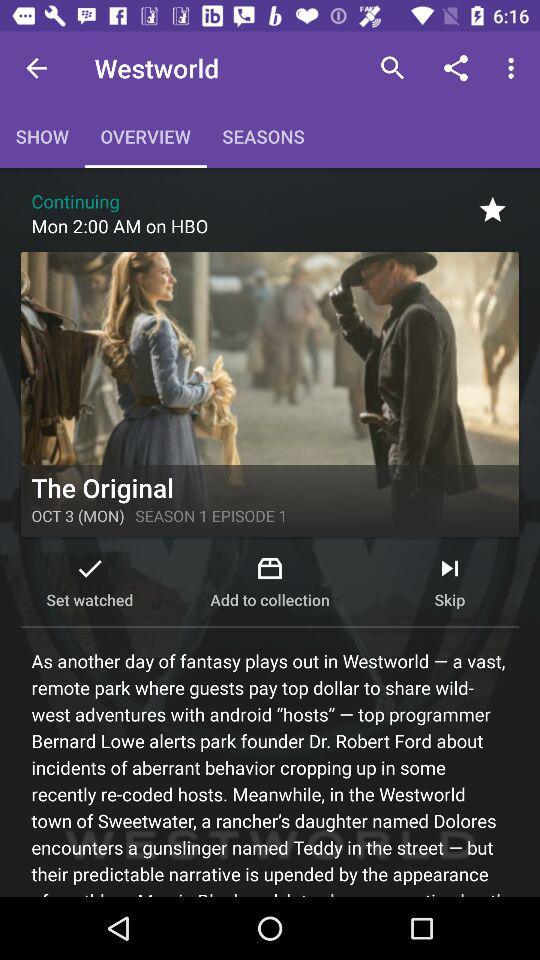What is the season of the drama? The season of the drama is 1. 